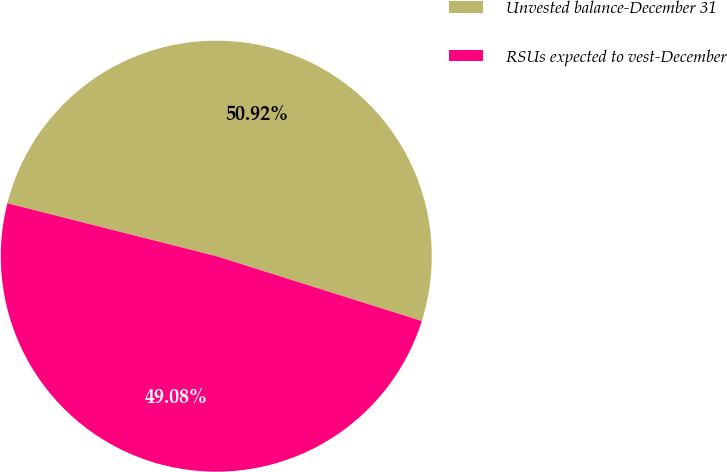Convert chart. <chart><loc_0><loc_0><loc_500><loc_500><pie_chart><fcel>Unvested balance-December 31<fcel>RSUs expected to vest-December<nl><fcel>50.92%<fcel>49.08%<nl></chart> 